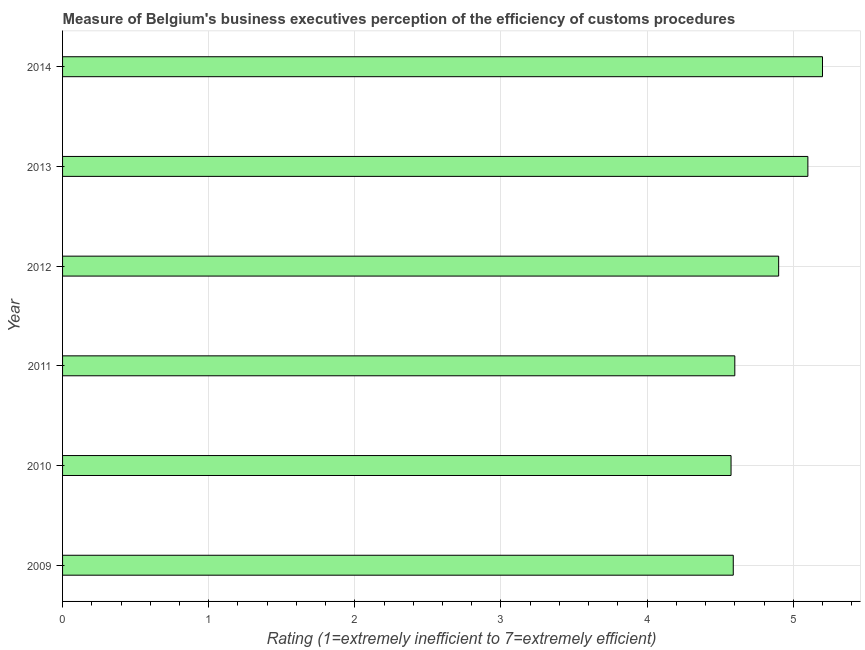Does the graph contain any zero values?
Offer a terse response. No. Does the graph contain grids?
Provide a succinct answer. Yes. What is the title of the graph?
Make the answer very short. Measure of Belgium's business executives perception of the efficiency of customs procedures. What is the label or title of the X-axis?
Your answer should be very brief. Rating (1=extremely inefficient to 7=extremely efficient). What is the label or title of the Y-axis?
Keep it short and to the point. Year. What is the rating measuring burden of customs procedure in 2013?
Offer a very short reply. 5.1. Across all years, what is the maximum rating measuring burden of customs procedure?
Provide a succinct answer. 5.2. Across all years, what is the minimum rating measuring burden of customs procedure?
Offer a terse response. 4.57. In which year was the rating measuring burden of customs procedure maximum?
Offer a terse response. 2014. In which year was the rating measuring burden of customs procedure minimum?
Your response must be concise. 2010. What is the sum of the rating measuring burden of customs procedure?
Make the answer very short. 28.96. What is the difference between the rating measuring burden of customs procedure in 2010 and 2012?
Ensure brevity in your answer.  -0.33. What is the average rating measuring burden of customs procedure per year?
Offer a terse response. 4.83. What is the median rating measuring burden of customs procedure?
Your answer should be compact. 4.75. In how many years, is the rating measuring burden of customs procedure greater than 2.4 ?
Give a very brief answer. 6. What is the difference between the highest and the second highest rating measuring burden of customs procedure?
Your answer should be compact. 0.1. Is the sum of the rating measuring burden of customs procedure in 2009 and 2012 greater than the maximum rating measuring burden of customs procedure across all years?
Give a very brief answer. Yes. What is the difference between the highest and the lowest rating measuring burden of customs procedure?
Offer a terse response. 0.63. Are all the bars in the graph horizontal?
Give a very brief answer. Yes. What is the difference between two consecutive major ticks on the X-axis?
Offer a very short reply. 1. What is the Rating (1=extremely inefficient to 7=extremely efficient) of 2009?
Your response must be concise. 4.59. What is the Rating (1=extremely inefficient to 7=extremely efficient) of 2010?
Provide a succinct answer. 4.57. What is the Rating (1=extremely inefficient to 7=extremely efficient) in 2011?
Your answer should be very brief. 4.6. What is the Rating (1=extremely inefficient to 7=extremely efficient) of 2013?
Provide a succinct answer. 5.1. What is the Rating (1=extremely inefficient to 7=extremely efficient) of 2014?
Offer a terse response. 5.2. What is the difference between the Rating (1=extremely inefficient to 7=extremely efficient) in 2009 and 2010?
Your answer should be very brief. 0.02. What is the difference between the Rating (1=extremely inefficient to 7=extremely efficient) in 2009 and 2011?
Your answer should be compact. -0.01. What is the difference between the Rating (1=extremely inefficient to 7=extremely efficient) in 2009 and 2012?
Make the answer very short. -0.31. What is the difference between the Rating (1=extremely inefficient to 7=extremely efficient) in 2009 and 2013?
Make the answer very short. -0.51. What is the difference between the Rating (1=extremely inefficient to 7=extremely efficient) in 2009 and 2014?
Offer a terse response. -0.61. What is the difference between the Rating (1=extremely inefficient to 7=extremely efficient) in 2010 and 2011?
Your answer should be compact. -0.03. What is the difference between the Rating (1=extremely inefficient to 7=extremely efficient) in 2010 and 2012?
Provide a short and direct response. -0.33. What is the difference between the Rating (1=extremely inefficient to 7=extremely efficient) in 2010 and 2013?
Offer a terse response. -0.53. What is the difference between the Rating (1=extremely inefficient to 7=extremely efficient) in 2010 and 2014?
Offer a very short reply. -0.63. What is the difference between the Rating (1=extremely inefficient to 7=extremely efficient) in 2011 and 2014?
Your answer should be compact. -0.6. What is the ratio of the Rating (1=extremely inefficient to 7=extremely efficient) in 2009 to that in 2010?
Offer a terse response. 1. What is the ratio of the Rating (1=extremely inefficient to 7=extremely efficient) in 2009 to that in 2011?
Ensure brevity in your answer.  1. What is the ratio of the Rating (1=extremely inefficient to 7=extremely efficient) in 2009 to that in 2012?
Your answer should be compact. 0.94. What is the ratio of the Rating (1=extremely inefficient to 7=extremely efficient) in 2009 to that in 2014?
Provide a succinct answer. 0.88. What is the ratio of the Rating (1=extremely inefficient to 7=extremely efficient) in 2010 to that in 2012?
Offer a very short reply. 0.93. What is the ratio of the Rating (1=extremely inefficient to 7=extremely efficient) in 2010 to that in 2013?
Ensure brevity in your answer.  0.9. What is the ratio of the Rating (1=extremely inefficient to 7=extremely efficient) in 2011 to that in 2012?
Provide a succinct answer. 0.94. What is the ratio of the Rating (1=extremely inefficient to 7=extremely efficient) in 2011 to that in 2013?
Your answer should be very brief. 0.9. What is the ratio of the Rating (1=extremely inefficient to 7=extremely efficient) in 2011 to that in 2014?
Your answer should be very brief. 0.89. What is the ratio of the Rating (1=extremely inefficient to 7=extremely efficient) in 2012 to that in 2014?
Your response must be concise. 0.94. 